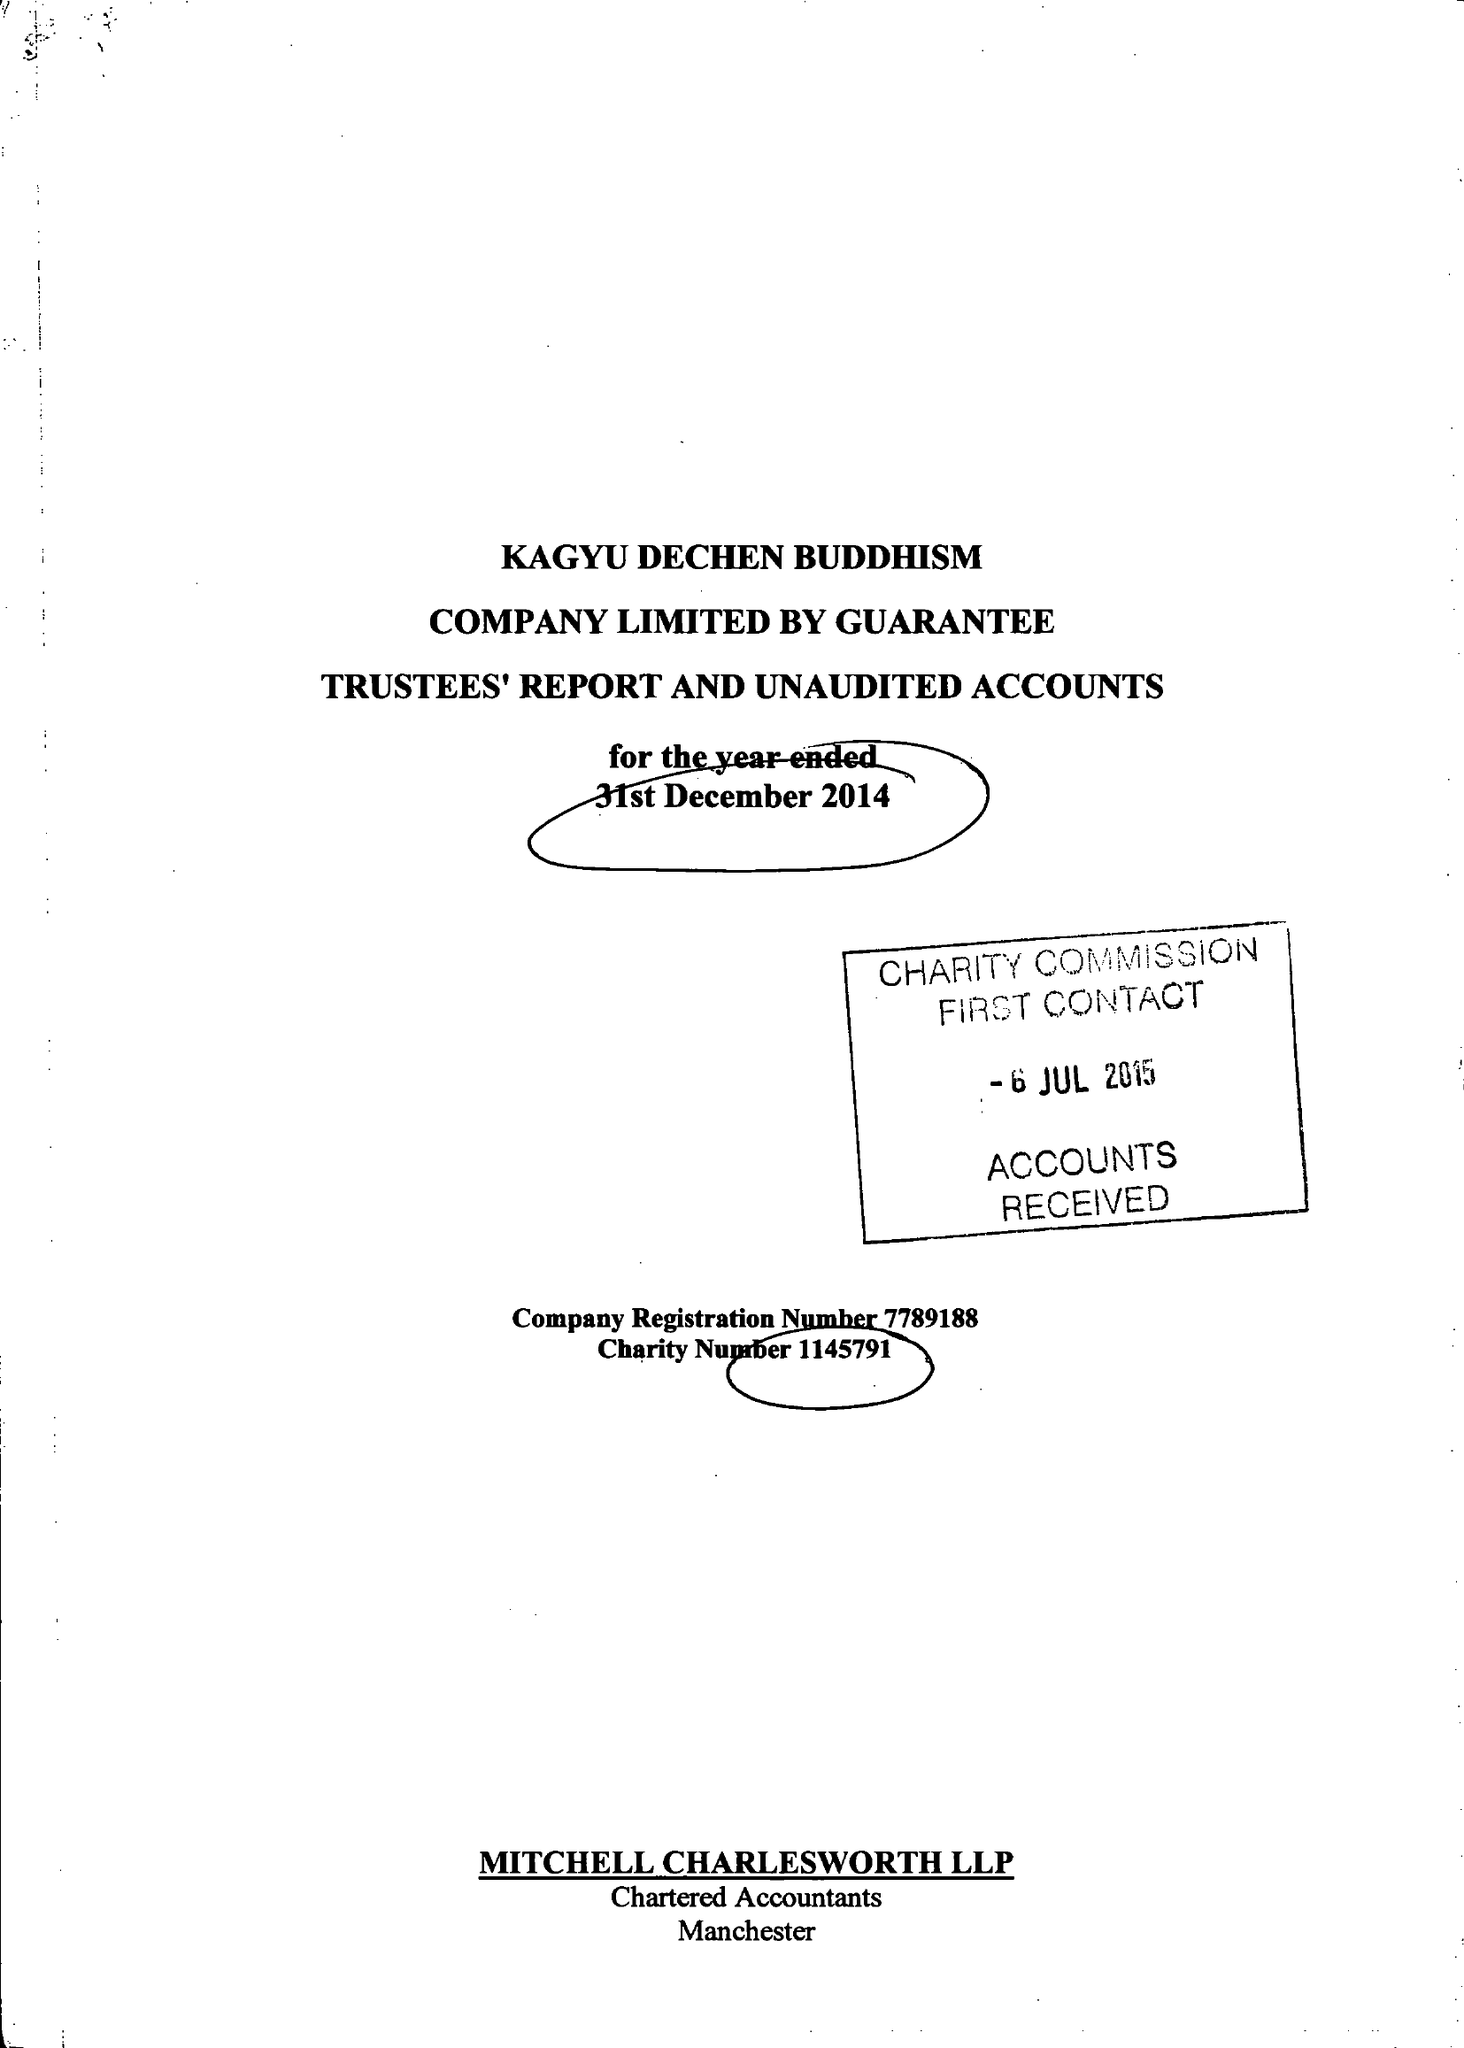What is the value for the address__post_town?
Answer the question using a single word or phrase. MANCHESTER 